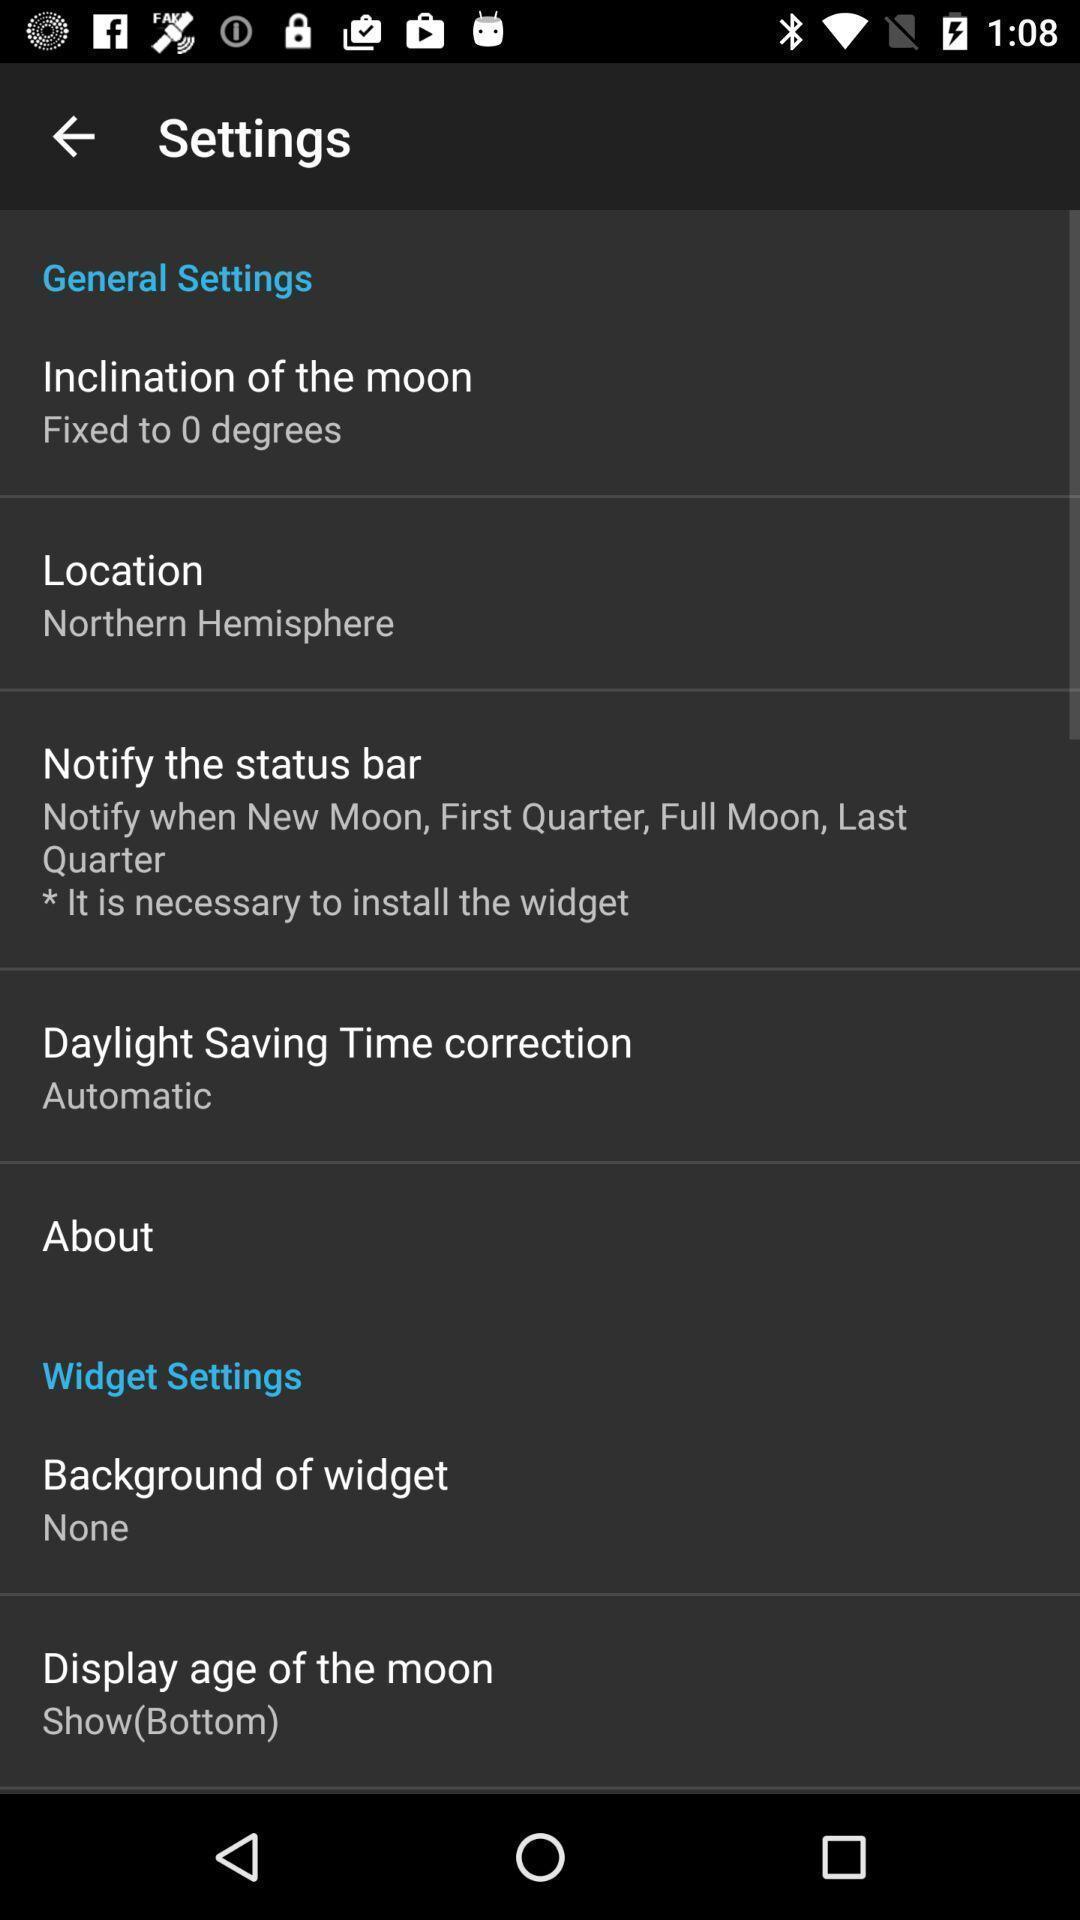Explain what's happening in this screen capture. Settings page. 